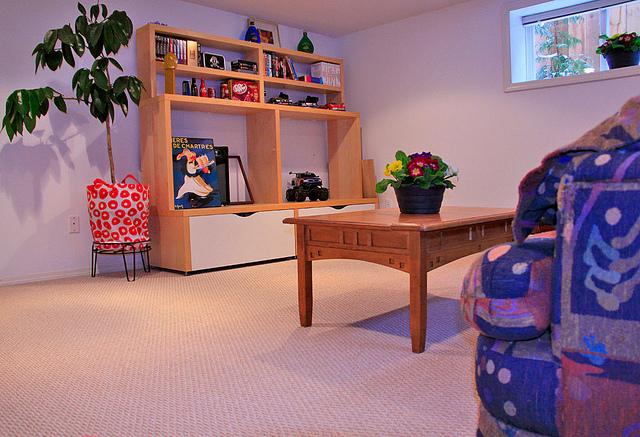Does the couch fabric have a pattern?
Give a very brief answer. Yes. What kind of room is this?
Quick response, please. Living room. Is this family room?
Give a very brief answer. Yes. 